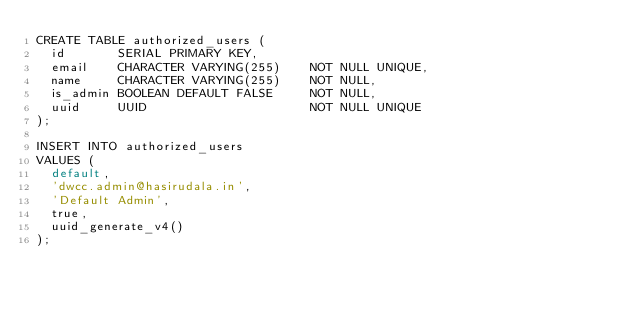<code> <loc_0><loc_0><loc_500><loc_500><_SQL_>CREATE TABLE authorized_users (
  id       SERIAL PRIMARY KEY,
  email    CHARACTER VARYING(255)    NOT NULL UNIQUE,
  name     CHARACTER VARYING(255)    NOT NULL,
  is_admin BOOLEAN DEFAULT FALSE     NOT NULL,
  uuid     UUID                      NOT NULL UNIQUE
);

INSERT INTO authorized_users
VALUES (
  default,
  'dwcc.admin@hasirudala.in',
  'Default Admin',
  true,
  uuid_generate_v4()
);
</code> 